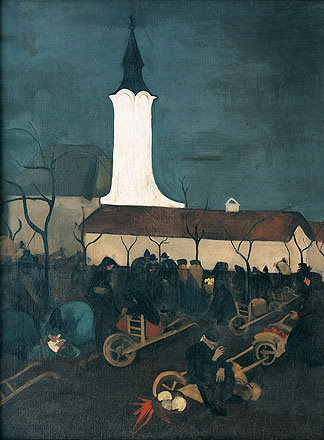What might the villagers be preparing for in this scene? The villagers seem to be preparing for a night-time event that could likely be an observatory gathering, as hinted by the inclusion of ladders and wheelbarrows possibly used for setting up telescopes or other viewing equipment. The communal effort, along with the church's prominent, lit-up steeple, suggests a significant local event that brings the community together in anticipation. 